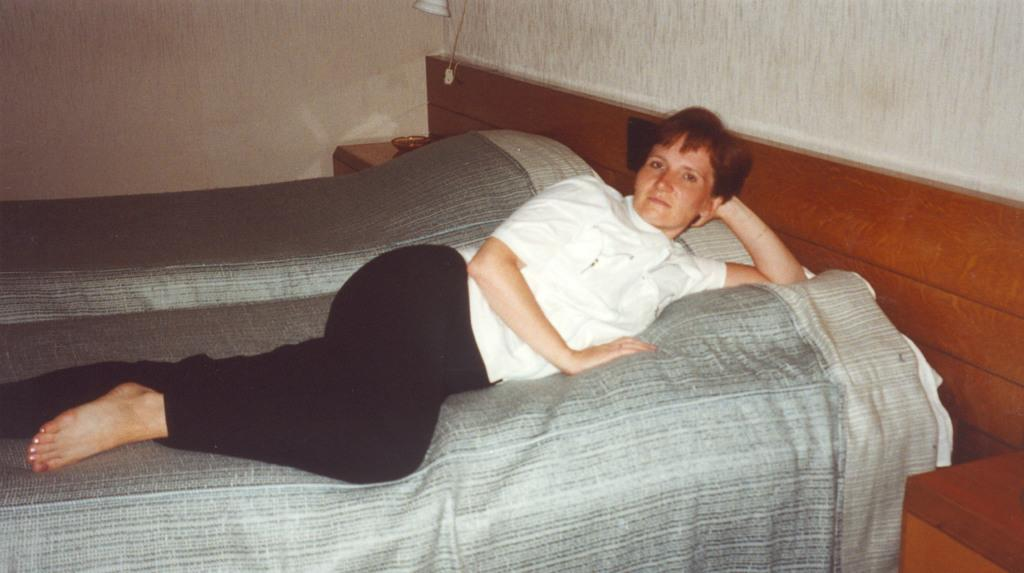What is the person in the image doing? The person is lying on the bed. What color is the person's t-shirt? The person is wearing a white t-shirt. What color are the person's pants? The person is wearing black pants. What color is the bed sheet? The bed sheet is grey in color. What can be seen behind the bed? There are walls behind the bed. What is attached to the wall? A lamp is attached to the wall. What type of religious symbol can be seen on the person's t-shirt? There is no religious symbol visible on the person's t-shirt; it is a plain white t-shirt. 